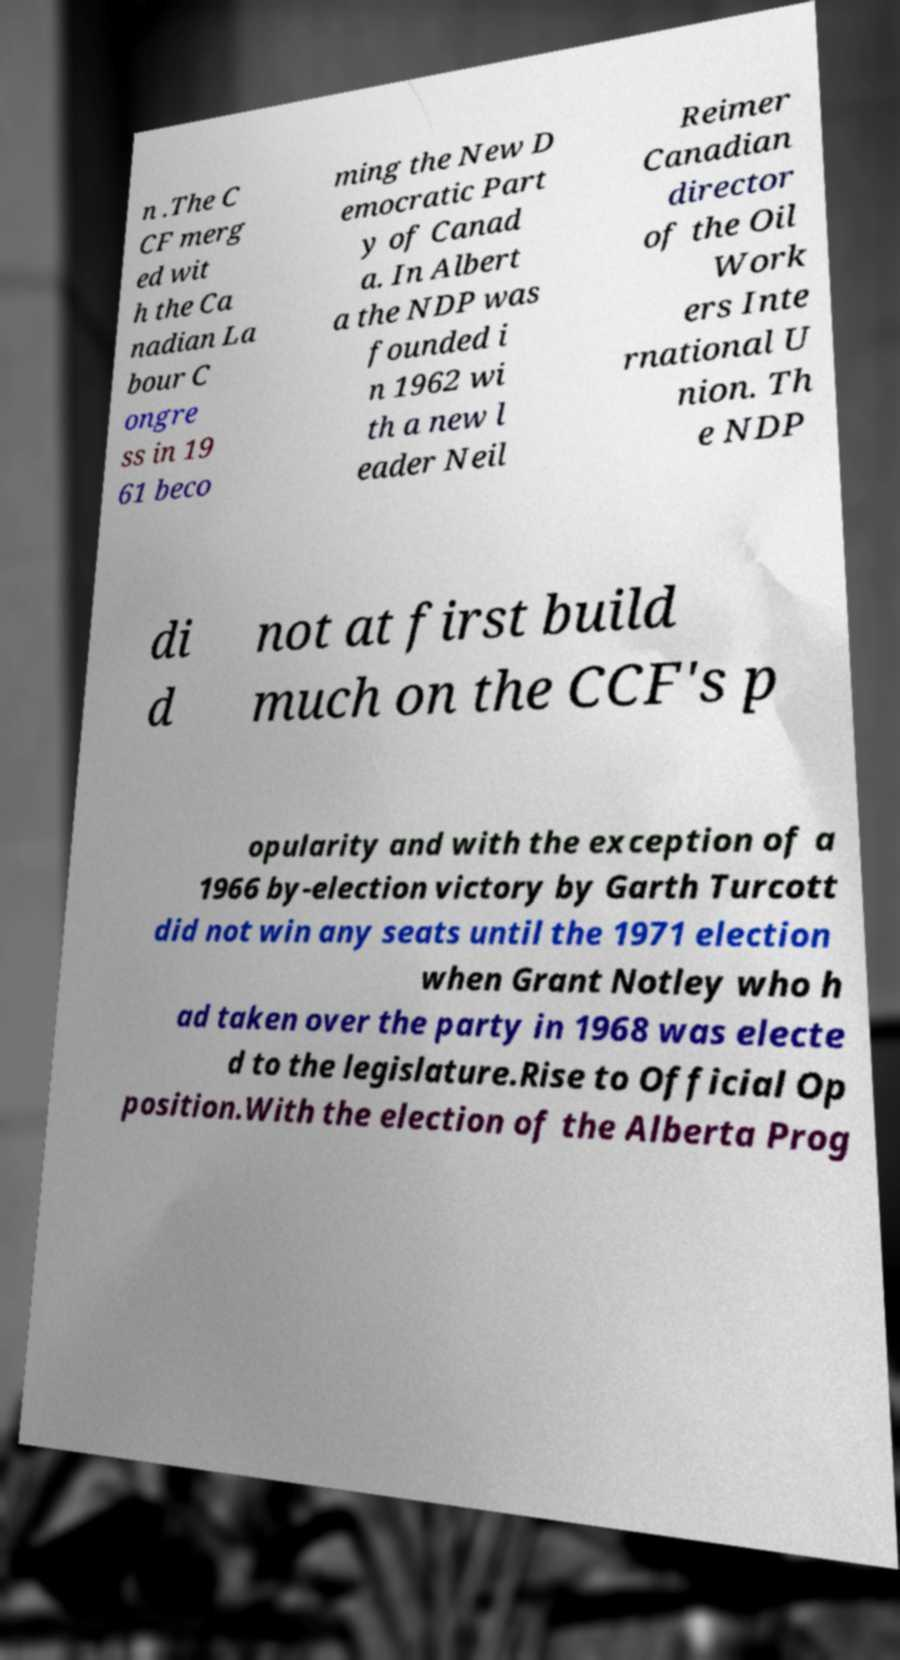Can you read and provide the text displayed in the image?This photo seems to have some interesting text. Can you extract and type it out for me? n .The C CF merg ed wit h the Ca nadian La bour C ongre ss in 19 61 beco ming the New D emocratic Part y of Canad a. In Albert a the NDP was founded i n 1962 wi th a new l eader Neil Reimer Canadian director of the Oil Work ers Inte rnational U nion. Th e NDP di d not at first build much on the CCF's p opularity and with the exception of a 1966 by-election victory by Garth Turcott did not win any seats until the 1971 election when Grant Notley who h ad taken over the party in 1968 was electe d to the legislature.Rise to Official Op position.With the election of the Alberta Prog 